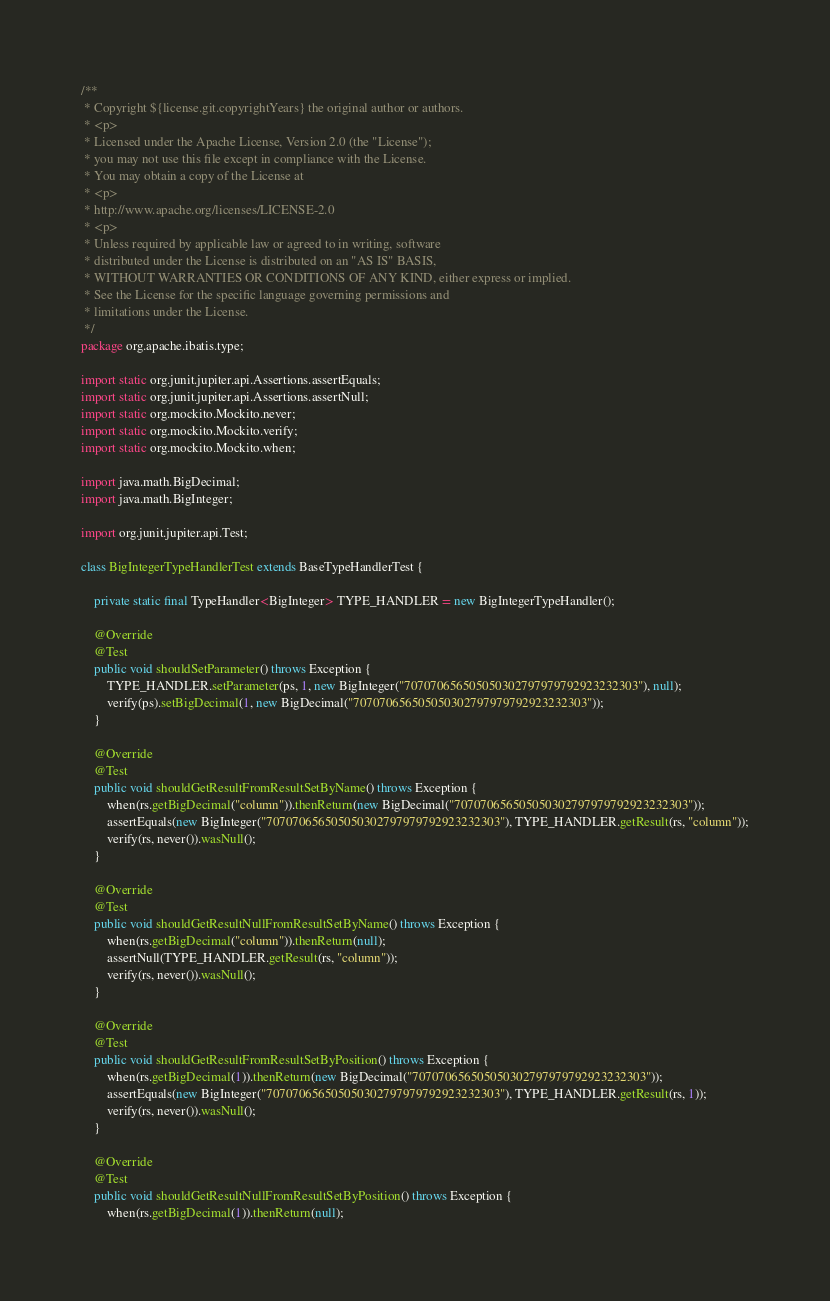<code> <loc_0><loc_0><loc_500><loc_500><_Java_>/**
 * Copyright ${license.git.copyrightYears} the original author or authors.
 * <p>
 * Licensed under the Apache License, Version 2.0 (the "License");
 * you may not use this file except in compliance with the License.
 * You may obtain a copy of the License at
 * <p>
 * http://www.apache.org/licenses/LICENSE-2.0
 * <p>
 * Unless required by applicable law or agreed to in writing, software
 * distributed under the License is distributed on an "AS IS" BASIS,
 * WITHOUT WARRANTIES OR CONDITIONS OF ANY KIND, either express or implied.
 * See the License for the specific language governing permissions and
 * limitations under the License.
 */
package org.apache.ibatis.type;

import static org.junit.jupiter.api.Assertions.assertEquals;
import static org.junit.jupiter.api.Assertions.assertNull;
import static org.mockito.Mockito.never;
import static org.mockito.Mockito.verify;
import static org.mockito.Mockito.when;

import java.math.BigDecimal;
import java.math.BigInteger;

import org.junit.jupiter.api.Test;

class BigIntegerTypeHandlerTest extends BaseTypeHandlerTest {

    private static final TypeHandler<BigInteger> TYPE_HANDLER = new BigIntegerTypeHandler();

    @Override
    @Test
    public void shouldSetParameter() throws Exception {
        TYPE_HANDLER.setParameter(ps, 1, new BigInteger("707070656505050302797979792923232303"), null);
        verify(ps).setBigDecimal(1, new BigDecimal("707070656505050302797979792923232303"));
    }

    @Override
    @Test
    public void shouldGetResultFromResultSetByName() throws Exception {
        when(rs.getBigDecimal("column")).thenReturn(new BigDecimal("707070656505050302797979792923232303"));
        assertEquals(new BigInteger("707070656505050302797979792923232303"), TYPE_HANDLER.getResult(rs, "column"));
        verify(rs, never()).wasNull();
    }

    @Override
    @Test
    public void shouldGetResultNullFromResultSetByName() throws Exception {
        when(rs.getBigDecimal("column")).thenReturn(null);
        assertNull(TYPE_HANDLER.getResult(rs, "column"));
        verify(rs, never()).wasNull();
    }

    @Override
    @Test
    public void shouldGetResultFromResultSetByPosition() throws Exception {
        when(rs.getBigDecimal(1)).thenReturn(new BigDecimal("707070656505050302797979792923232303"));
        assertEquals(new BigInteger("707070656505050302797979792923232303"), TYPE_HANDLER.getResult(rs, 1));
        verify(rs, never()).wasNull();
    }

    @Override
    @Test
    public void shouldGetResultNullFromResultSetByPosition() throws Exception {
        when(rs.getBigDecimal(1)).thenReturn(null);</code> 